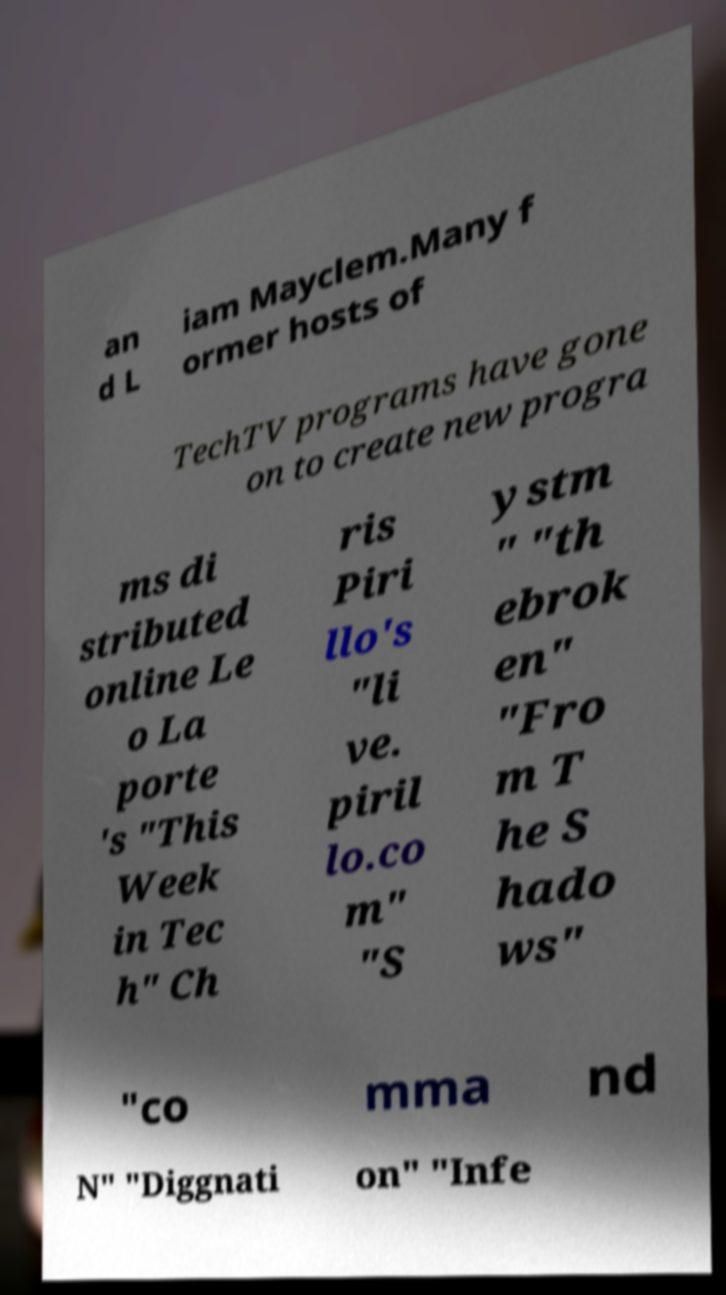There's text embedded in this image that I need extracted. Can you transcribe it verbatim? an d L iam Mayclem.Many f ormer hosts of TechTV programs have gone on to create new progra ms di stributed online Le o La porte 's "This Week in Tec h" Ch ris Piri llo's "li ve. piril lo.co m" "S ystm " "th ebrok en" "Fro m T he S hado ws" "co mma nd N" "Diggnati on" "Infe 